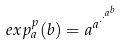Convert formula to latex. <formula><loc_0><loc_0><loc_500><loc_500>e x p _ { a } ^ { p } ( b ) = a ^ { a ^ { \cdot ^ { \cdot ^ { a ^ { b } } } } }</formula> 